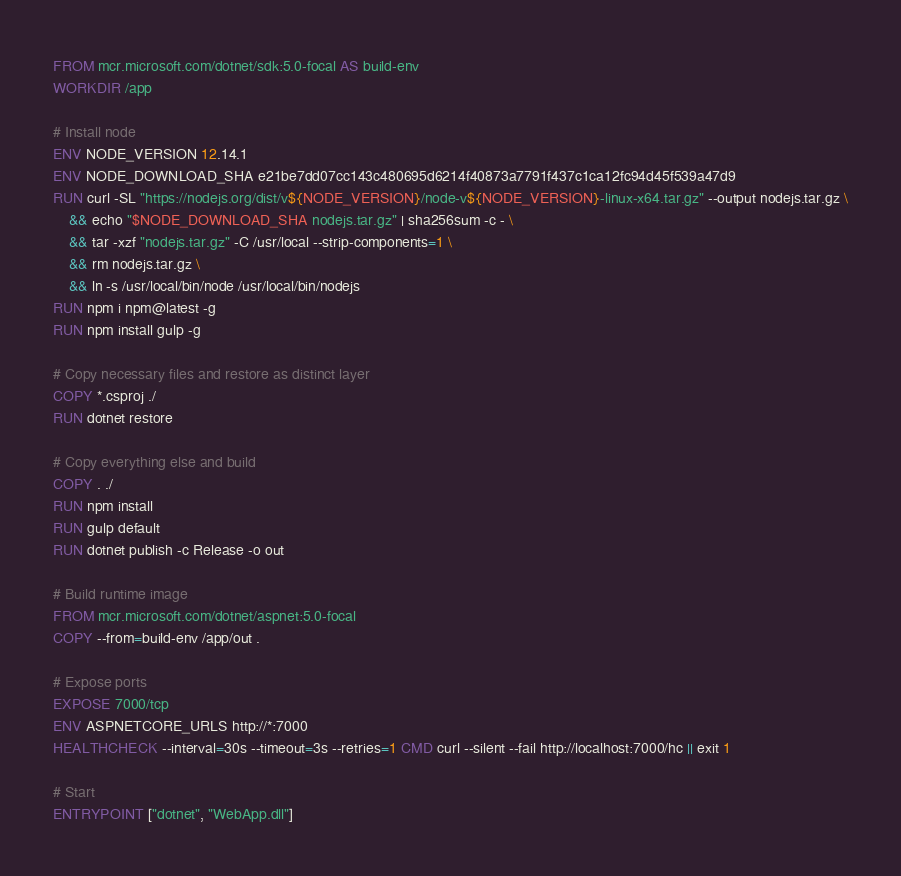Convert code to text. <code><loc_0><loc_0><loc_500><loc_500><_Dockerfile_>FROM mcr.microsoft.com/dotnet/sdk:5.0-focal AS build-env
WORKDIR /app

# Install node
ENV NODE_VERSION 12.14.1
ENV NODE_DOWNLOAD_SHA e21be7dd07cc143c480695d6214f40873a7791f437c1ca12fc94d45f539a47d9
RUN curl -SL "https://nodejs.org/dist/v${NODE_VERSION}/node-v${NODE_VERSION}-linux-x64.tar.gz" --output nodejs.tar.gz \
    && echo "$NODE_DOWNLOAD_SHA nodejs.tar.gz" | sha256sum -c - \
    && tar -xzf "nodejs.tar.gz" -C /usr/local --strip-components=1 \
    && rm nodejs.tar.gz \
    && ln -s /usr/local/bin/node /usr/local/bin/nodejs
RUN npm i npm@latest -g
RUN npm install gulp -g

# Copy necessary files and restore as distinct layer
COPY *.csproj ./
RUN dotnet restore

# Copy everything else and build
COPY . ./
RUN npm install
RUN gulp default
RUN dotnet publish -c Release -o out

# Build runtime image
FROM mcr.microsoft.com/dotnet/aspnet:5.0-focal
COPY --from=build-env /app/out .

# Expose ports
EXPOSE 7000/tcp
ENV ASPNETCORE_URLS http://*:7000
HEALTHCHECK --interval=30s --timeout=3s --retries=1 CMD curl --silent --fail http://localhost:7000/hc || exit 1

# Start
ENTRYPOINT ["dotnet", "WebApp.dll"]
</code> 